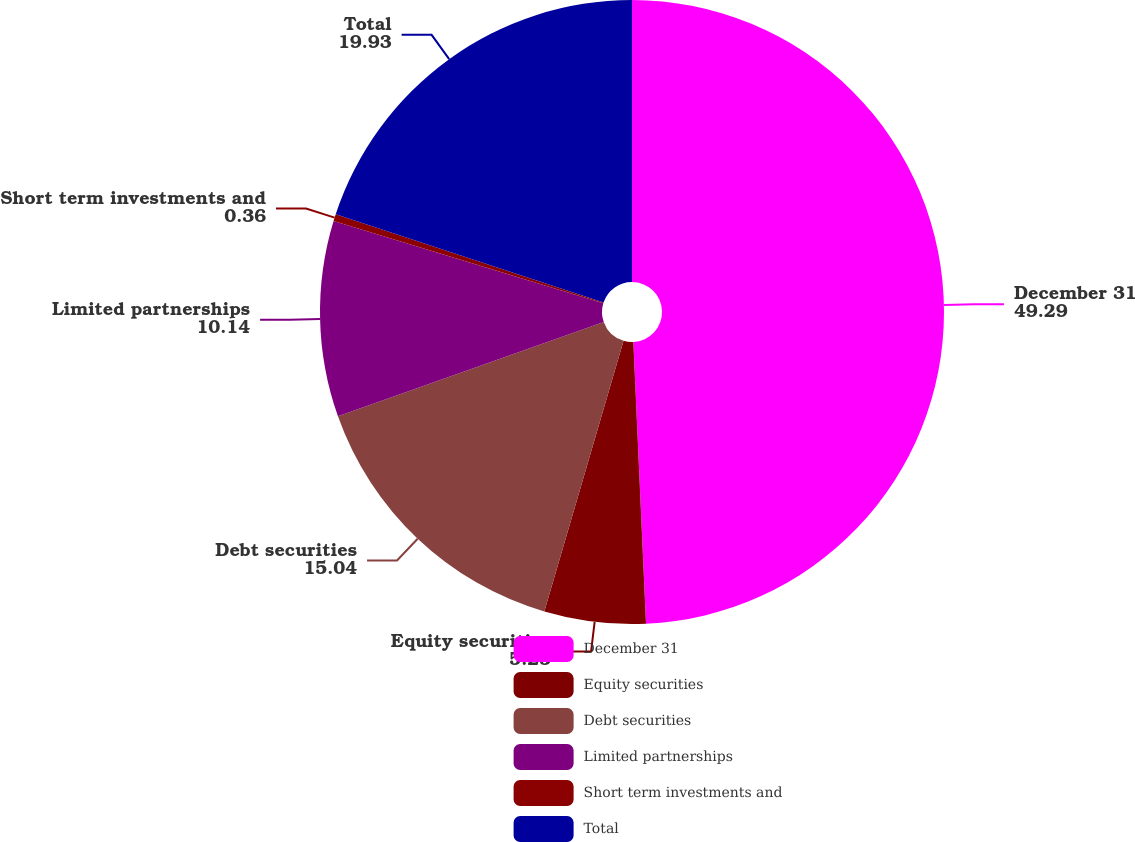Convert chart to OTSL. <chart><loc_0><loc_0><loc_500><loc_500><pie_chart><fcel>December 31<fcel>Equity securities<fcel>Debt securities<fcel>Limited partnerships<fcel>Short term investments and<fcel>Total<nl><fcel>49.29%<fcel>5.25%<fcel>15.04%<fcel>10.14%<fcel>0.36%<fcel>19.93%<nl></chart> 